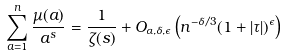<formula> <loc_0><loc_0><loc_500><loc_500>\sum _ { a = 1 } ^ { n } \frac { \mu ( a ) } { a ^ { s } } = \frac { 1 } { \zeta ( s ) } + O _ { \alpha , \delta , \epsilon } \left ( n ^ { - \delta / 3 } ( 1 + | \tau | ) ^ { \epsilon } \right )</formula> 